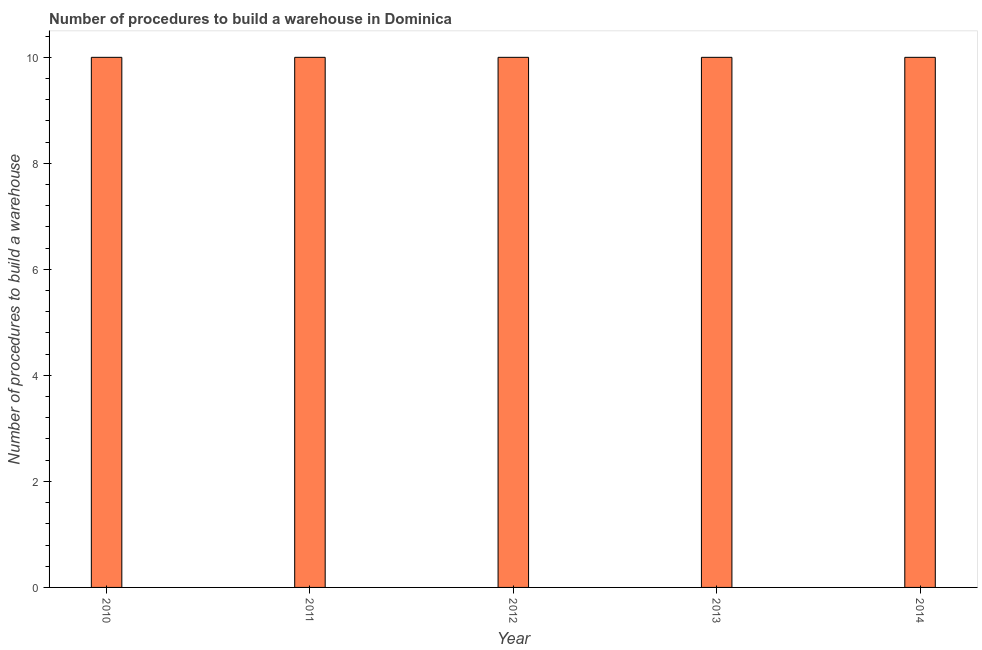Does the graph contain any zero values?
Give a very brief answer. No. Does the graph contain grids?
Your answer should be compact. No. What is the title of the graph?
Provide a succinct answer. Number of procedures to build a warehouse in Dominica. What is the label or title of the Y-axis?
Give a very brief answer. Number of procedures to build a warehouse. What is the number of procedures to build a warehouse in 2010?
Your answer should be compact. 10. Across all years, what is the maximum number of procedures to build a warehouse?
Provide a succinct answer. 10. Across all years, what is the minimum number of procedures to build a warehouse?
Give a very brief answer. 10. In which year was the number of procedures to build a warehouse minimum?
Provide a succinct answer. 2010. What is the difference between the number of procedures to build a warehouse in 2011 and 2013?
Your response must be concise. 0. In how many years, is the number of procedures to build a warehouse greater than 0.4 ?
Make the answer very short. 5. What is the ratio of the number of procedures to build a warehouse in 2010 to that in 2011?
Ensure brevity in your answer.  1. Is the difference between the number of procedures to build a warehouse in 2011 and 2014 greater than the difference between any two years?
Provide a short and direct response. Yes. What is the difference between the highest and the second highest number of procedures to build a warehouse?
Make the answer very short. 0. Is the sum of the number of procedures to build a warehouse in 2010 and 2011 greater than the maximum number of procedures to build a warehouse across all years?
Offer a terse response. Yes. What is the difference between the highest and the lowest number of procedures to build a warehouse?
Make the answer very short. 0. How many bars are there?
Your answer should be very brief. 5. Are all the bars in the graph horizontal?
Your answer should be compact. No. Are the values on the major ticks of Y-axis written in scientific E-notation?
Make the answer very short. No. What is the Number of procedures to build a warehouse in 2012?
Give a very brief answer. 10. What is the Number of procedures to build a warehouse in 2013?
Make the answer very short. 10. What is the Number of procedures to build a warehouse in 2014?
Offer a very short reply. 10. What is the difference between the Number of procedures to build a warehouse in 2010 and 2011?
Keep it short and to the point. 0. What is the difference between the Number of procedures to build a warehouse in 2010 and 2013?
Make the answer very short. 0. What is the difference between the Number of procedures to build a warehouse in 2010 and 2014?
Your response must be concise. 0. What is the difference between the Number of procedures to build a warehouse in 2011 and 2012?
Make the answer very short. 0. What is the difference between the Number of procedures to build a warehouse in 2011 and 2013?
Provide a short and direct response. 0. What is the difference between the Number of procedures to build a warehouse in 2012 and 2013?
Make the answer very short. 0. What is the ratio of the Number of procedures to build a warehouse in 2010 to that in 2011?
Offer a very short reply. 1. What is the ratio of the Number of procedures to build a warehouse in 2010 to that in 2013?
Keep it short and to the point. 1. What is the ratio of the Number of procedures to build a warehouse in 2010 to that in 2014?
Offer a very short reply. 1. What is the ratio of the Number of procedures to build a warehouse in 2012 to that in 2013?
Offer a terse response. 1. What is the ratio of the Number of procedures to build a warehouse in 2012 to that in 2014?
Offer a terse response. 1. What is the ratio of the Number of procedures to build a warehouse in 2013 to that in 2014?
Your answer should be compact. 1. 